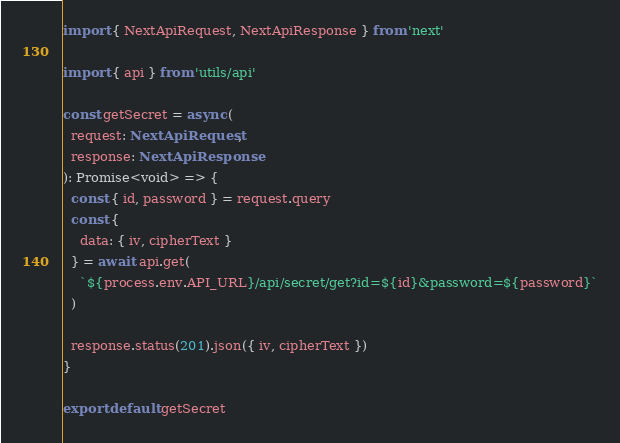Convert code to text. <code><loc_0><loc_0><loc_500><loc_500><_TypeScript_>import { NextApiRequest, NextApiResponse } from 'next'

import { api } from 'utils/api'

const getSecret = async (
  request: NextApiRequest,
  response: NextApiResponse
): Promise<void> => {
  const { id, password } = request.query
  const {
    data: { iv, cipherText }
  } = await api.get(
    `${process.env.API_URL}/api/secret/get?id=${id}&password=${password}`
  )

  response.status(201).json({ iv, cipherText })
}

export default getSecret
</code> 